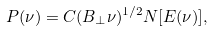<formula> <loc_0><loc_0><loc_500><loc_500>P ( \nu ) = C ( B _ { \perp } \nu ) ^ { 1 / 2 } N [ E ( \nu ) ] ,</formula> 